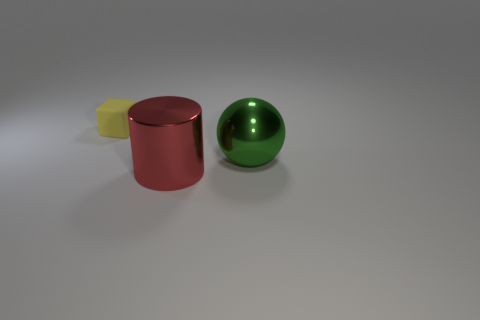Add 2 large green cylinders. How many objects exist? 5 Subtract all spheres. How many objects are left? 2 Subtract all yellow cylinders. Subtract all purple spheres. How many cylinders are left? 1 Subtract all red blocks. How many brown cylinders are left? 0 Subtract all tiny things. Subtract all small cylinders. How many objects are left? 2 Add 2 rubber things. How many rubber things are left? 3 Add 1 green metallic balls. How many green metallic balls exist? 2 Subtract 0 brown cylinders. How many objects are left? 3 